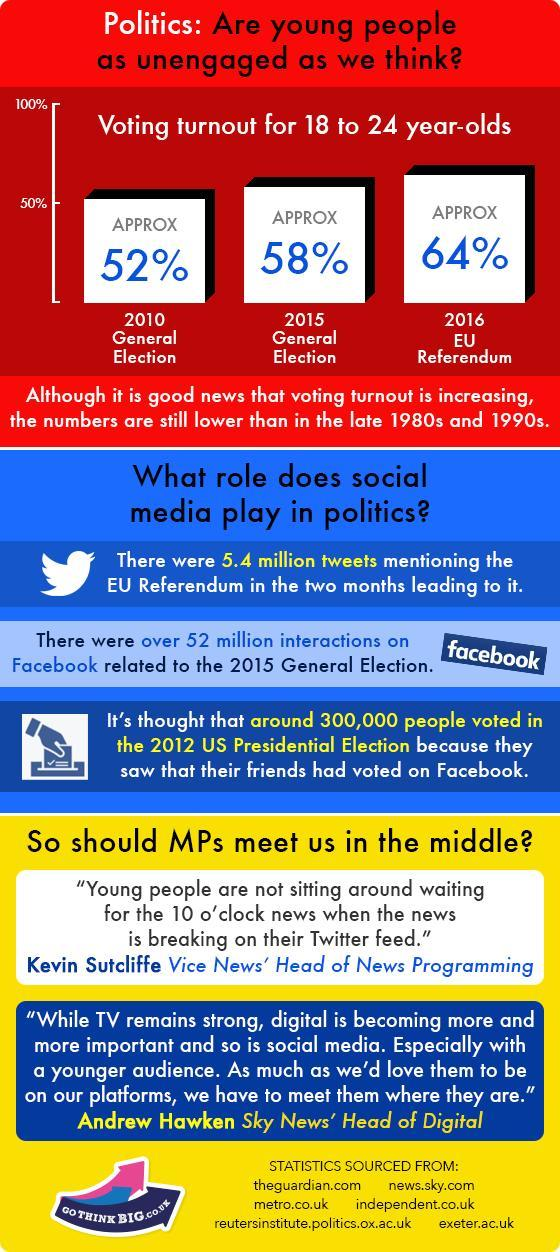What is the voter turnout for 18 to 24 year-olds during the 2015 General Election?
Answer the question with a short phrase. APPROX 58% 